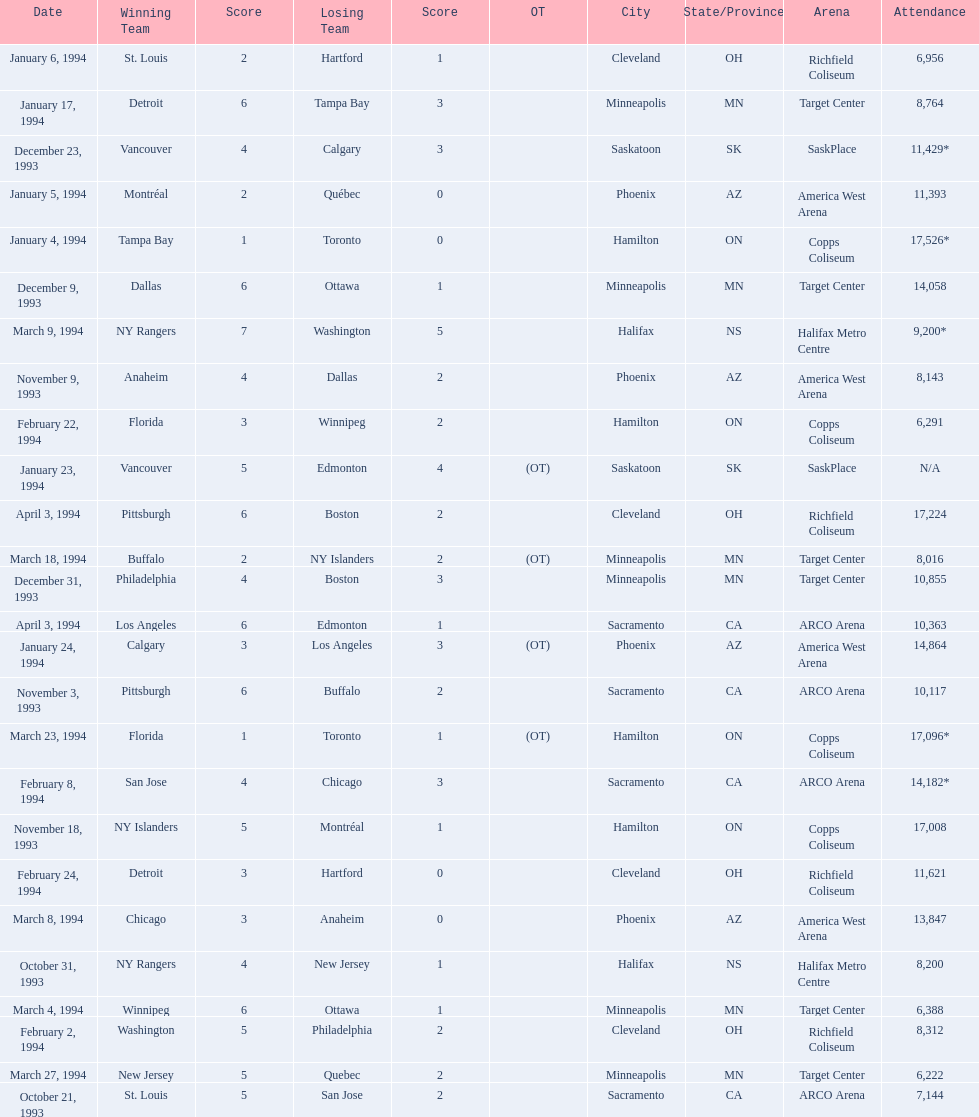What was the attendance on january 24, 1994? 14,864. What was the attendance on december 23, 1993? 11,429*. Between january 24, 1994 and december 23, 1993, which had the higher attendance? January 4, 1994. 